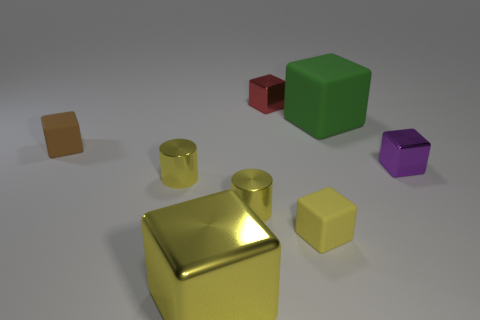What material is the tiny block that is the same color as the big metallic thing?
Your response must be concise. Rubber. What number of things are either yellow rubber objects or red metallic blocks?
Keep it short and to the point. 2. Does the yellow cylinder on the left side of the yellow metal cube have the same size as the green matte object that is behind the small brown object?
Your response must be concise. No. How many cubes are either tiny purple metallic things or tiny yellow metal things?
Provide a succinct answer. 1. Is there a tiny gray matte cylinder?
Make the answer very short. No. Is the big shiny thing the same color as the big rubber thing?
Keep it short and to the point. No. What number of things are either large blocks that are on the left side of the tiny red metal object or small cyan cylinders?
Give a very brief answer. 1. How many green things are behind the block that is right of the large object that is behind the brown cube?
Offer a terse response. 1. What shape is the big thing that is behind the yellow thing in front of the yellow cube that is right of the yellow shiny block?
Keep it short and to the point. Cube. What number of other things are there of the same color as the large metallic thing?
Keep it short and to the point. 3. 